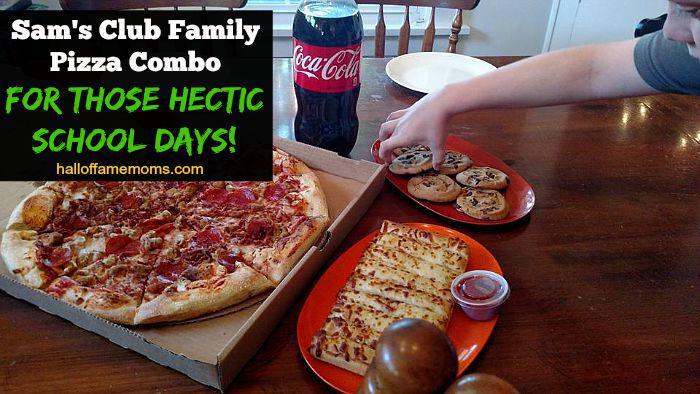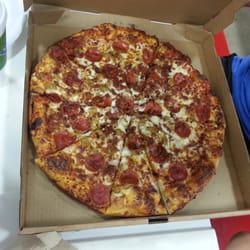The first image is the image on the left, the second image is the image on the right. For the images shown, is this caption "The left image includes a pizza in an open box, a plate containing a row of cheesy bread with a container of red sauce next to it, a plate of cookies, and a bottle of cola beside the pizza box." true? Answer yes or no. Yes. The first image is the image on the left, the second image is the image on the right. Considering the images on both sides, is "The pizza in the image on the right is lying in a cardboard box." valid? Answer yes or no. Yes. 